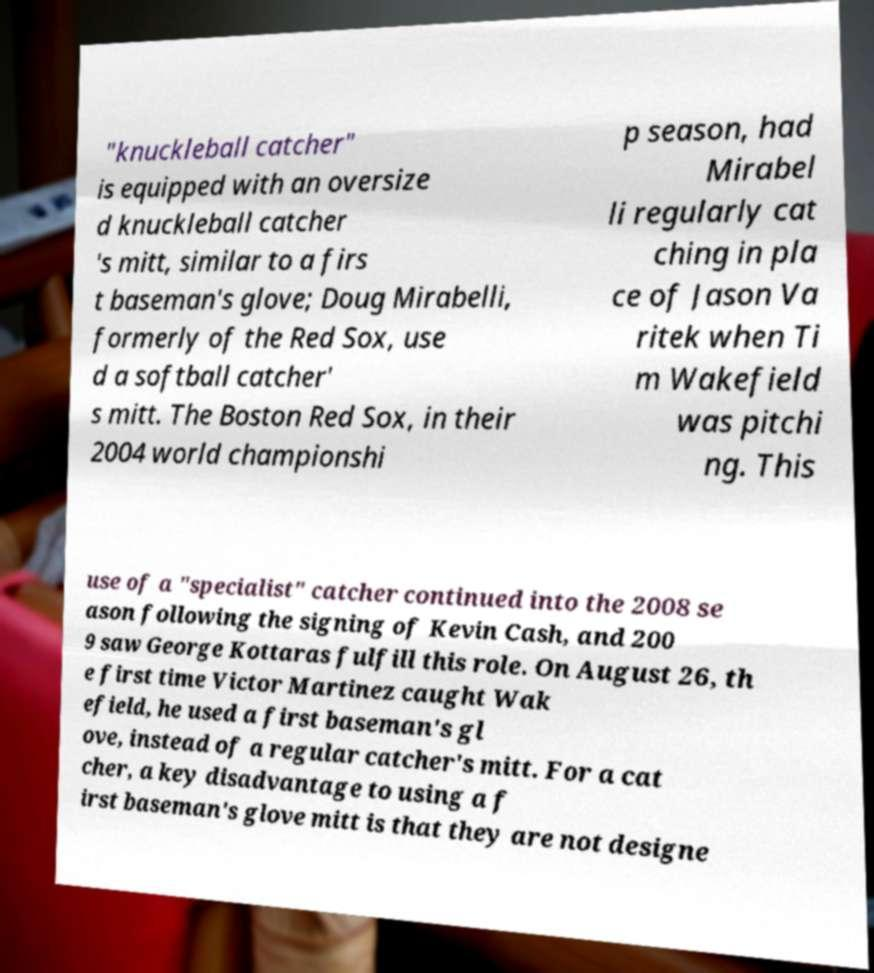For documentation purposes, I need the text within this image transcribed. Could you provide that? "knuckleball catcher" is equipped with an oversize d knuckleball catcher 's mitt, similar to a firs t baseman's glove; Doug Mirabelli, formerly of the Red Sox, use d a softball catcher' s mitt. The Boston Red Sox, in their 2004 world championshi p season, had Mirabel li regularly cat ching in pla ce of Jason Va ritek when Ti m Wakefield was pitchi ng. This use of a "specialist" catcher continued into the 2008 se ason following the signing of Kevin Cash, and 200 9 saw George Kottaras fulfill this role. On August 26, th e first time Victor Martinez caught Wak efield, he used a first baseman's gl ove, instead of a regular catcher's mitt. For a cat cher, a key disadvantage to using a f irst baseman's glove mitt is that they are not designe 